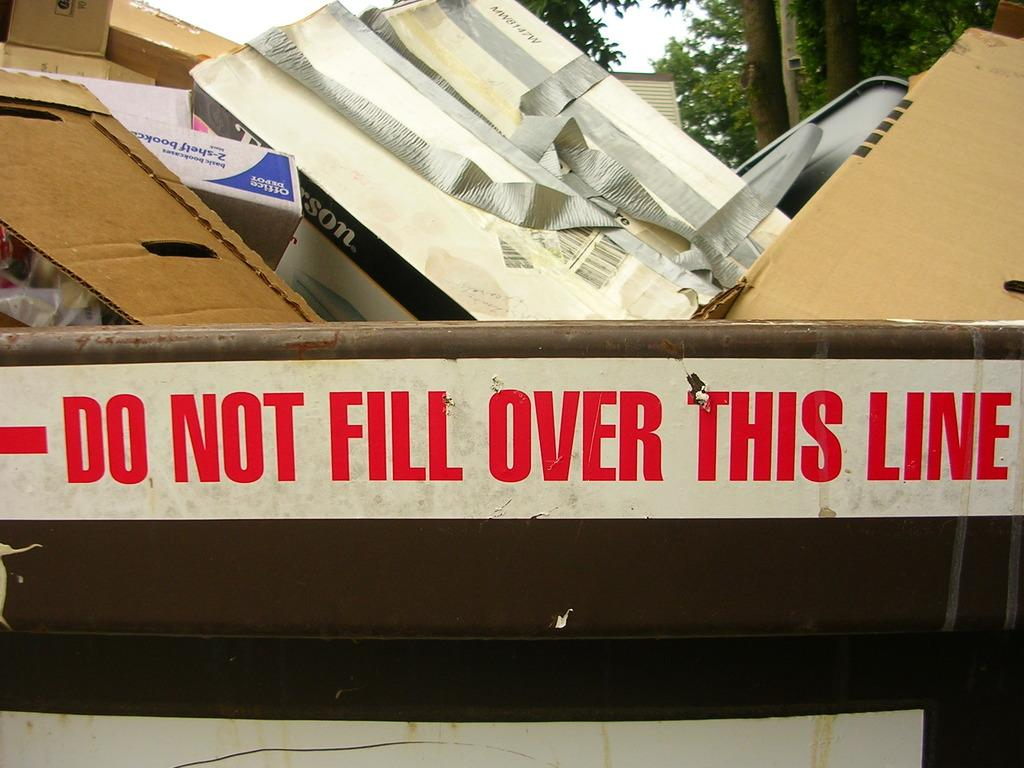<image>
Render a clear and concise summary of the photo. A trash can full of boxes and cardboard despite there is a warning to not fill it over the line. 